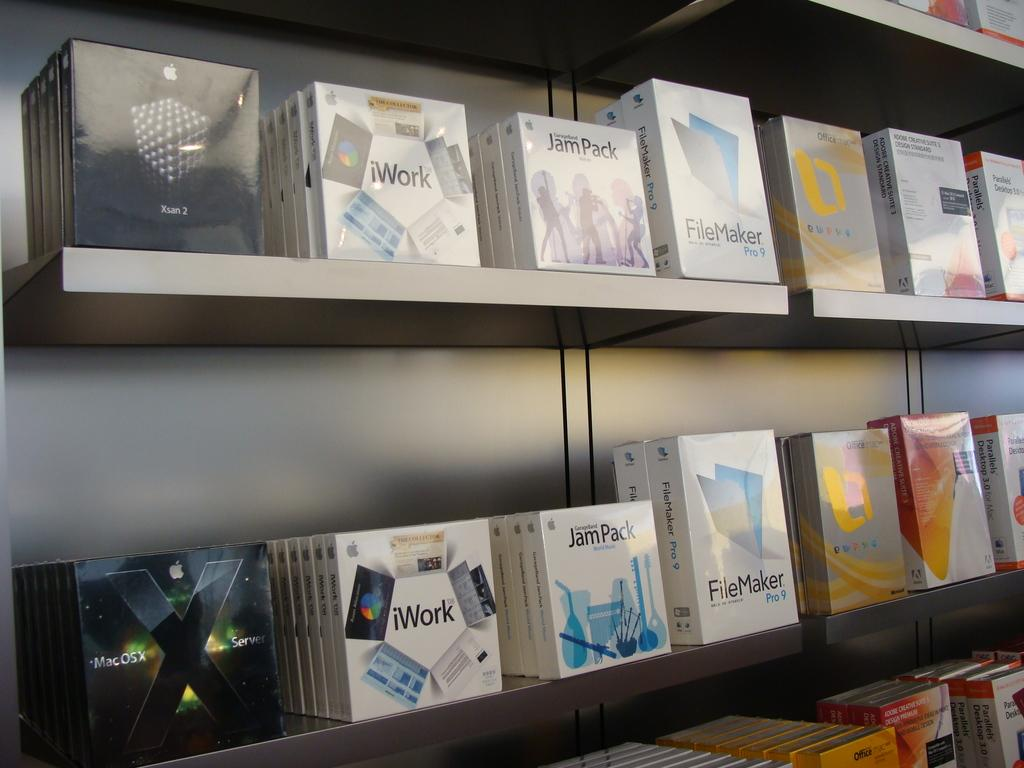<image>
Offer a succinct explanation of the picture presented. Shelves containing different computer software packages including iWork, JamPack, FileMaker and more. 